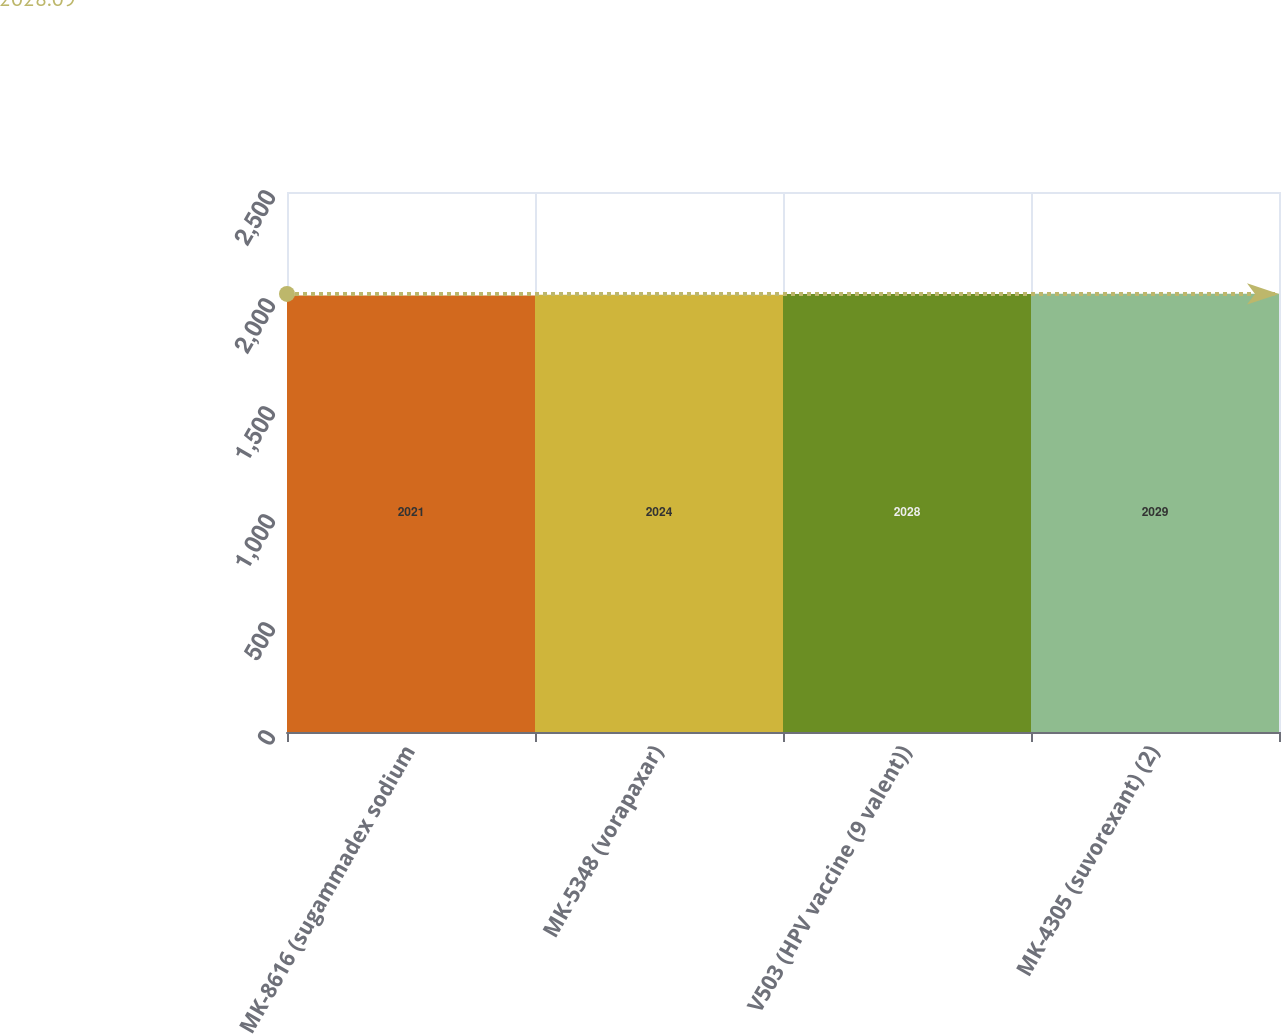<chart> <loc_0><loc_0><loc_500><loc_500><bar_chart><fcel>MK-8616 (sugammadex sodium<fcel>MK-5348 (vorapaxar)<fcel>V503 (HPV vaccine (9 valent))<fcel>MK-4305 (suvorexant) (2)<nl><fcel>2021<fcel>2024<fcel>2028<fcel>2029<nl></chart> 